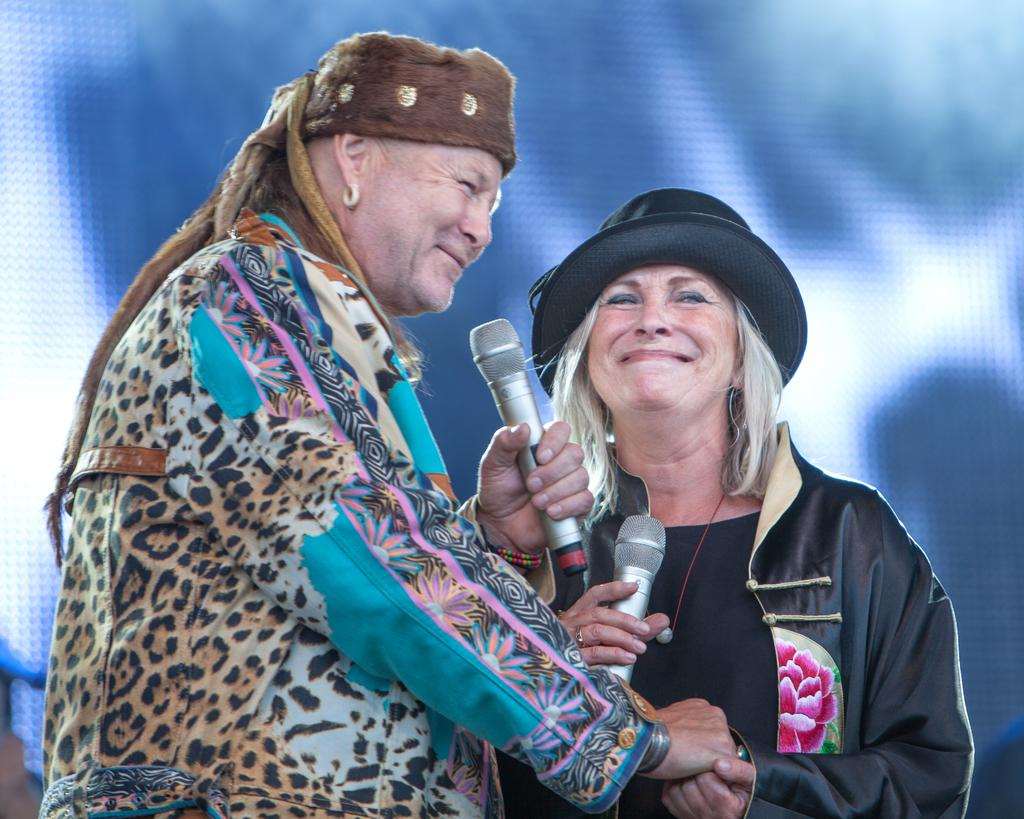How many people are in the image? There are two women in the image. What are the women doing in the image? The women are standing and holding microphones. What shape is the vest worn by the woman on the left in the image? There is no vest visible in the image, and therefore no shape can be determined. 